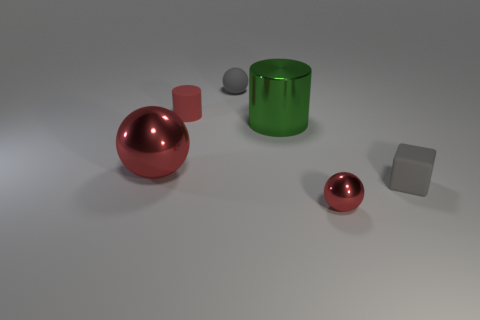What number of tiny cylinders have the same color as the tiny metal sphere?
Keep it short and to the point. 1. Are there any gray things in front of the green cylinder?
Make the answer very short. Yes. What size is the thing that is the same color as the small rubber ball?
Ensure brevity in your answer.  Small. Are there any gray things that have the same material as the small red ball?
Offer a very short reply. No. What is the color of the shiny cylinder?
Your response must be concise. Green. Does the metallic thing on the left side of the green cylinder have the same shape as the tiny shiny thing?
Give a very brief answer. Yes. The small rubber object that is on the left side of the gray thing behind the big object on the right side of the tiny cylinder is what shape?
Make the answer very short. Cylinder. There is a tiny sphere in front of the big green cylinder; what is its material?
Your answer should be compact. Metal. There is a cylinder that is the same size as the gray block; what is its color?
Your response must be concise. Red. How many other things are the same shape as the green metal object?
Ensure brevity in your answer.  1. 